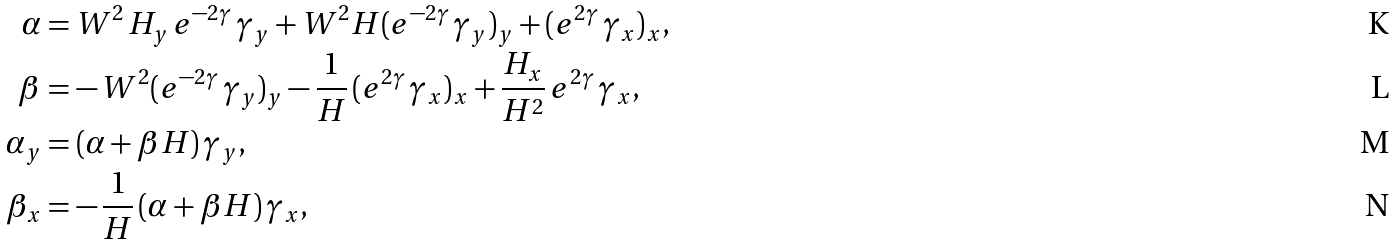Convert formula to latex. <formula><loc_0><loc_0><loc_500><loc_500>\alpha & = W ^ { 2 } \, H _ { y } \, e ^ { - 2 \gamma } \, \gamma _ { y } + W ^ { 2 } H ( e ^ { - 2 \gamma } \, \gamma _ { y } ) _ { y } + ( e ^ { 2 \gamma } \, \gamma _ { x } ) _ { x } , \\ \beta & = - \, W ^ { 2 } ( e ^ { - 2 \gamma } \, \gamma _ { y } ) _ { y } - \frac { 1 } { H } \, ( e ^ { 2 \gamma } \, \gamma _ { x } ) _ { x } + \frac { H _ { x } } { H ^ { 2 } } \, e ^ { 2 \gamma } \, \gamma _ { x } , \\ \alpha _ { y } & = ( \alpha + \beta H ) \, \gamma _ { y } , \\ \beta _ { x } & = - \, \frac { 1 } { H } \, ( \alpha + \beta H ) \, \gamma _ { x } ,</formula> 